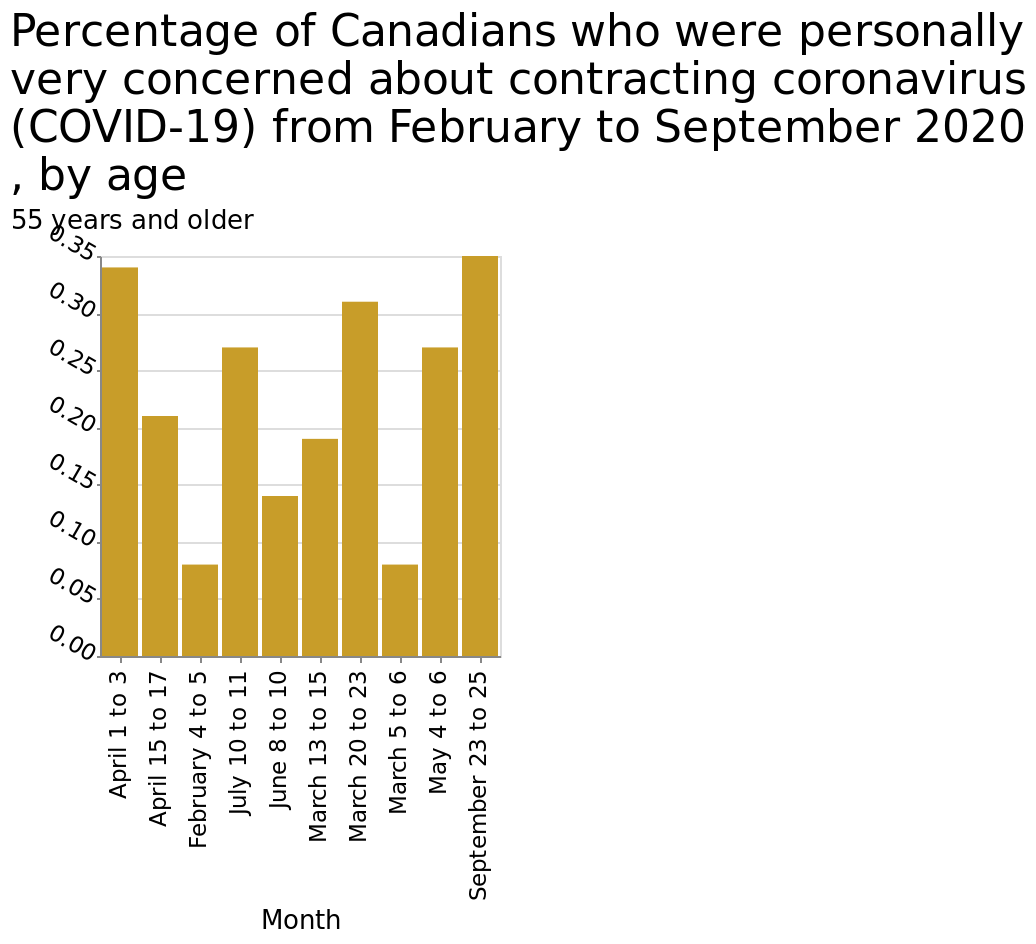<image>
please enumerates aspects of the construction of the chart This bar chart is called Percentage of Canadians who were personally very concerned about contracting coronavirus (COVID-19) from February to September 2020 , by age. The y-axis shows 55 years and older while the x-axis shows Month. 